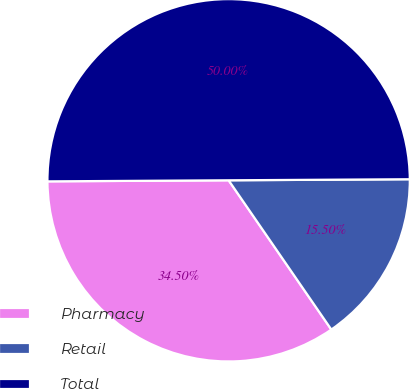Convert chart. <chart><loc_0><loc_0><loc_500><loc_500><pie_chart><fcel>Pharmacy<fcel>Retail<fcel>Total<nl><fcel>34.5%<fcel>15.5%<fcel>50.0%<nl></chart> 